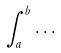<formula> <loc_0><loc_0><loc_500><loc_500>\int _ { a } ^ { b } \dots</formula> 